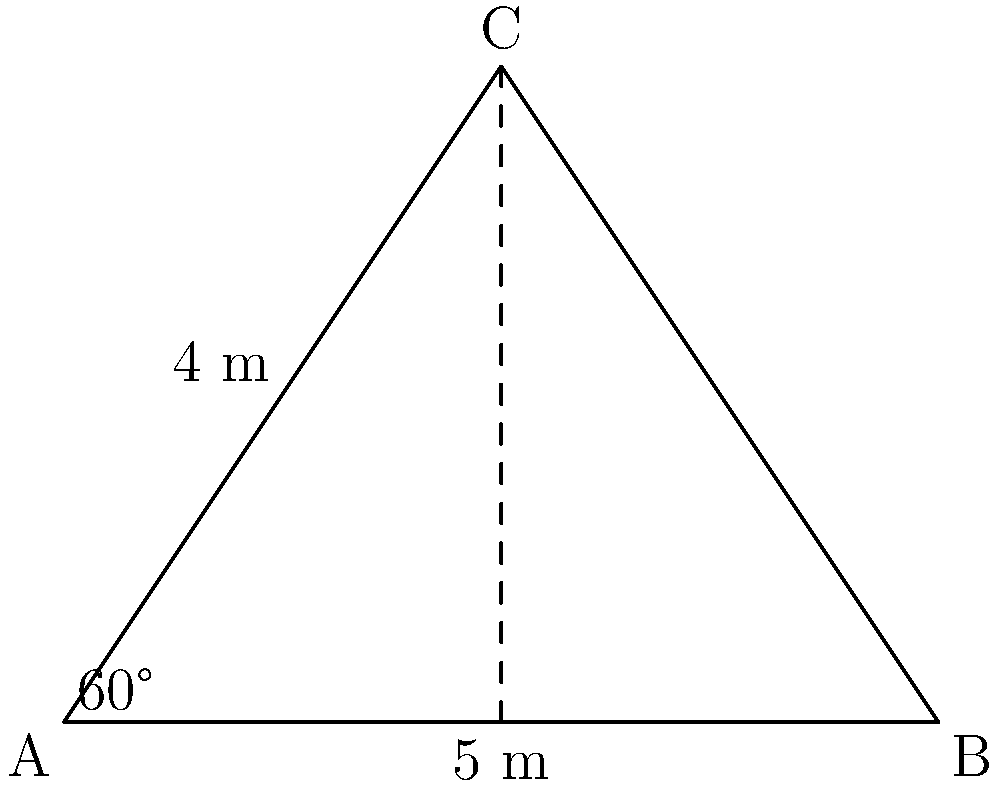A new computer science classroom is being designed in the shape of a triangle. The architect has provided the following information:
- One wall (AB) is 5 meters long
- Another wall (AC) is 4 meters long
- The angle between these walls is 60°

To ensure the room meets safety regulations, you need to determine if this classroom is congruent to a standard triangular classroom design with the same two side lengths and included angle. How would you justify this congruence using the Side-Angle-Side (SAS) criterion? To justify the congruence of the new classroom to the standard design using the Side-Angle-Side (SAS) criterion, we need to show that the three corresponding parts (two sides and the included angle) are equal. Let's break this down step-by-step:

1. Given information:
   - Side AB = 5 meters
   - Side AC = 4 meters
   - Angle A = 60°

2. SAS Congruence Criterion:
   Two triangles are congruent if two sides and the included angle of one triangle are equal to the corresponding parts of the other triangle.

3. Comparison with standard design:
   - If the standard design also has a 5-meter side, a 4-meter side, and a 60° angle between them, then we can apply the SAS criterion.

4. Application of SAS:
   - Side 1: AB (new classroom) = AB (standard design) = 5 meters
   - Side 2: AC (new classroom) = AC (standard design) = 4 meters
   - Included Angle: Angle A (new classroom) = Angle A (standard design) = 60°

5. Conclusion:
   Since the two sides and the included angle of the new classroom design are equal to the corresponding parts of the standard design, we can conclude that the triangles are congruent by the SAS criterion.

This congruence ensures that the new classroom will have the same shape and dimensions as the standard design, meeting safety regulations.
Answer: The new classroom is congruent to the standard design by SAS criterion: AB=5m, AC=4m, ∠A=60° in both designs. 